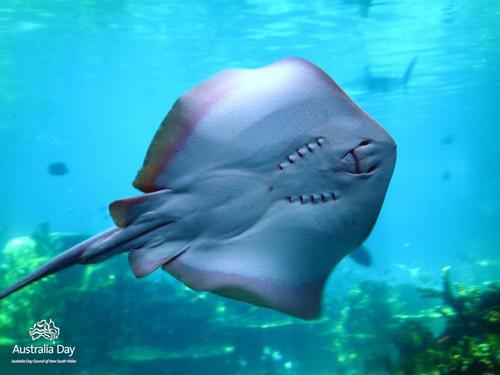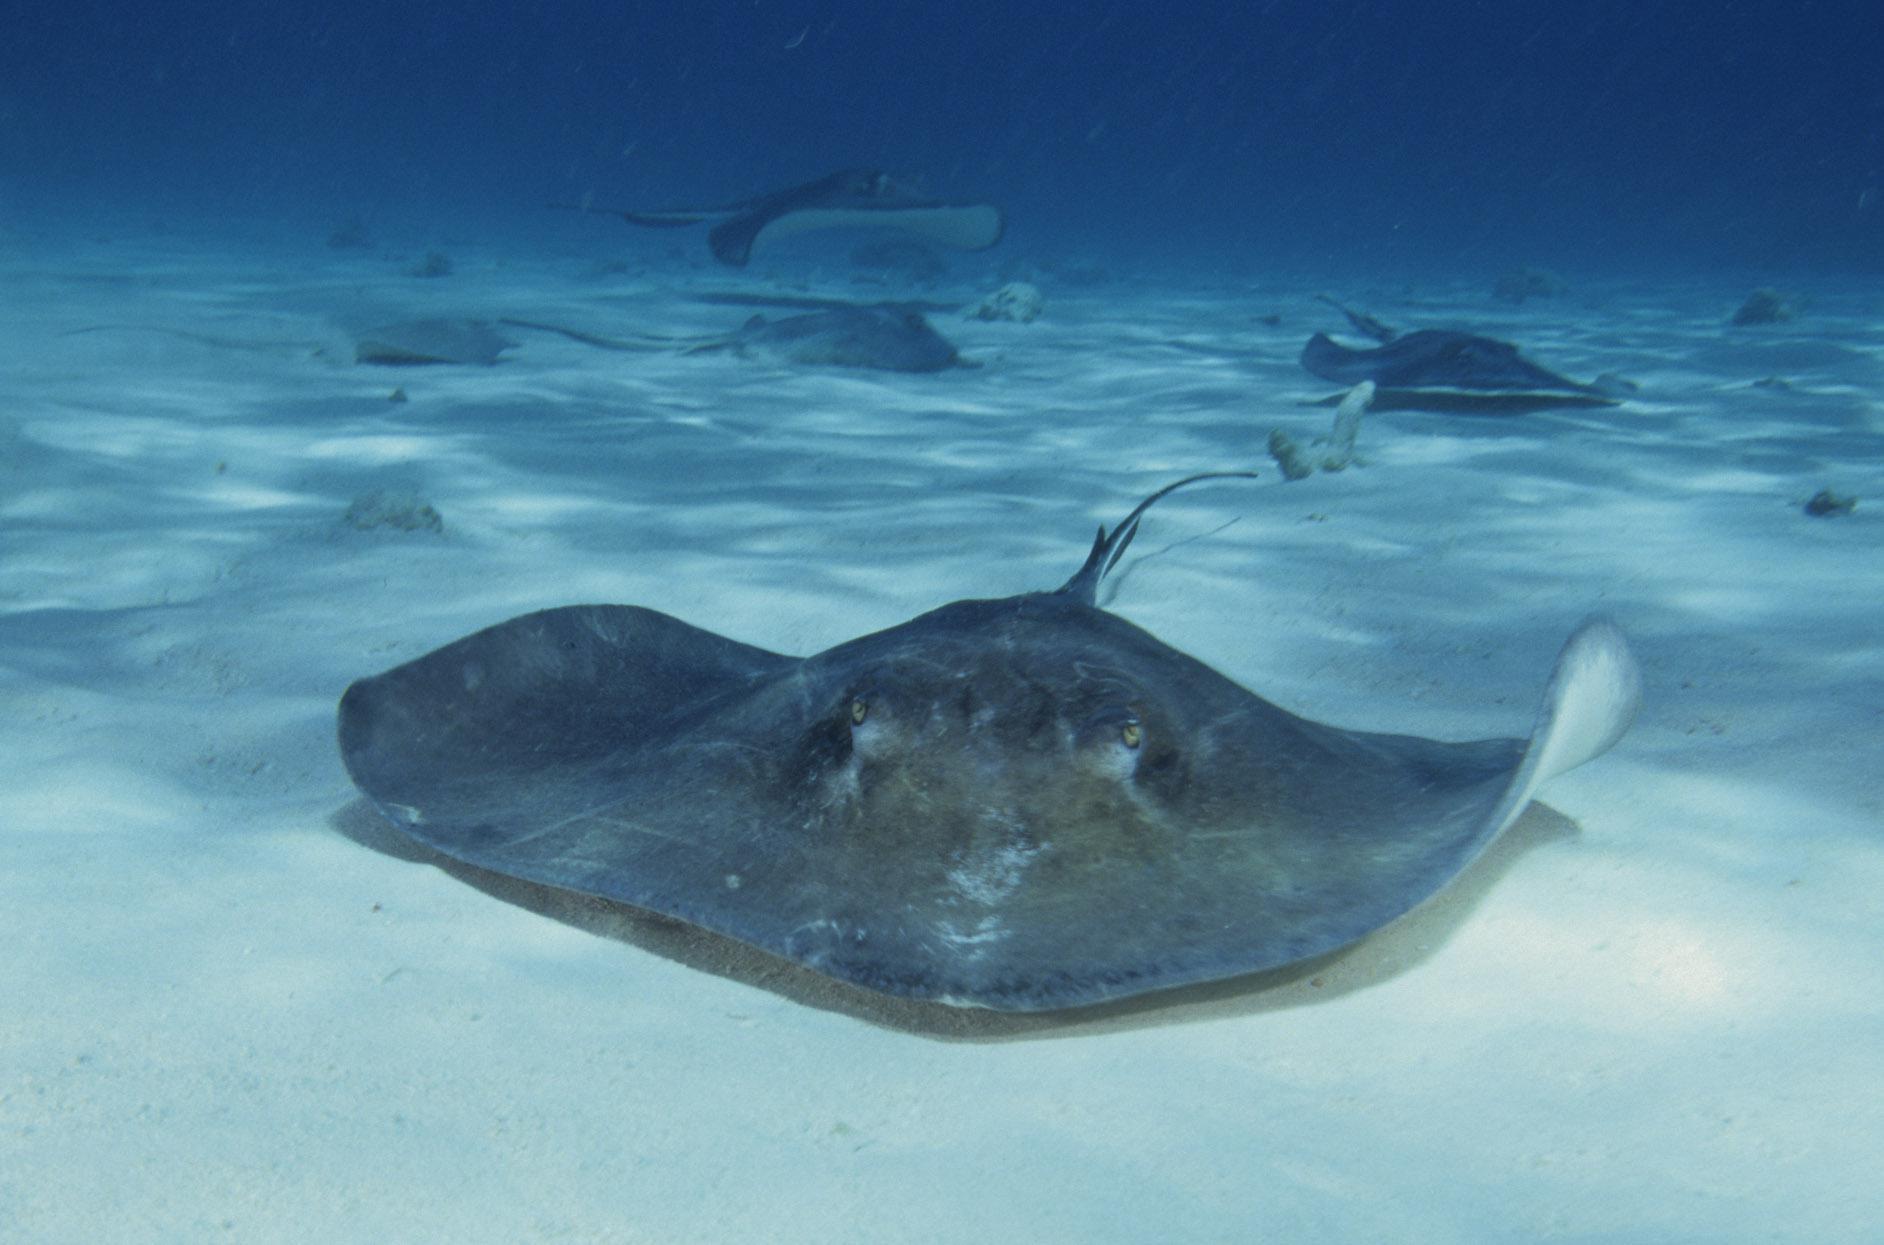The first image is the image on the left, the second image is the image on the right. Examine the images to the left and right. Is the description "The stingray on the left is viewed from underneath, showing its underside." accurate? Answer yes or no. Yes. 